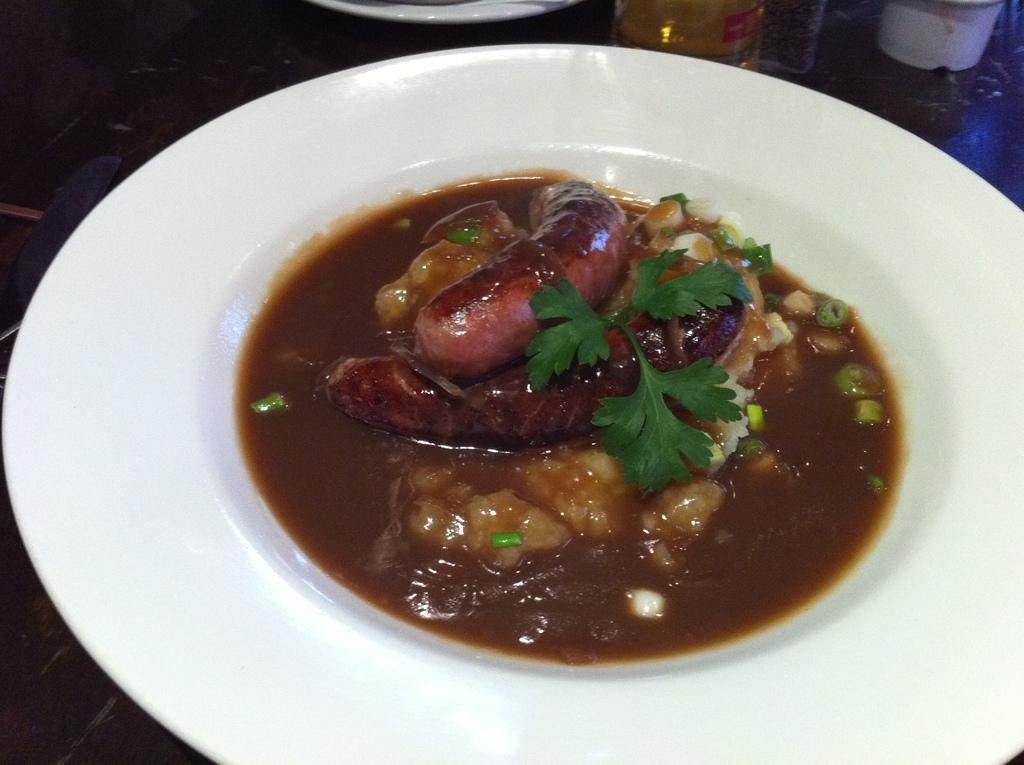What piece of furniture is present in the image? There is a table in the image. What is placed on the table? There is a plate on the table. What is on the plate? There is food in the plate. What can be seen in the background of the image? There are objects visible in the background of the image. What type of skirt is being worn by the person walking down the street in the image? There is no person or street present in the image, so it is not possible to answer that question. 